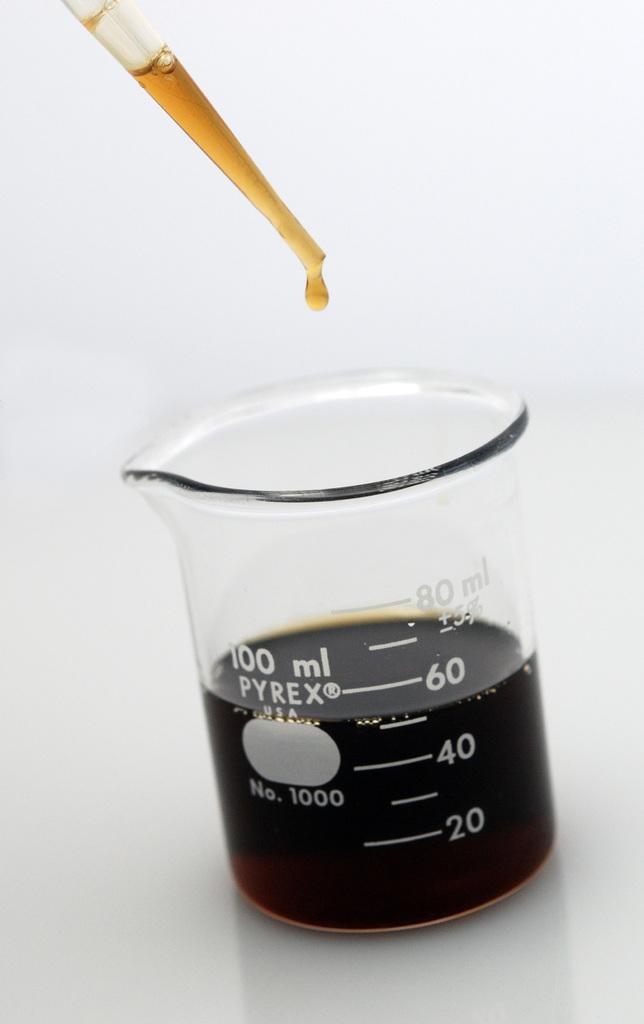How large is this beaker?
Offer a very short reply. 100ml. What company made the beaker?
Your response must be concise. Pyrex. 